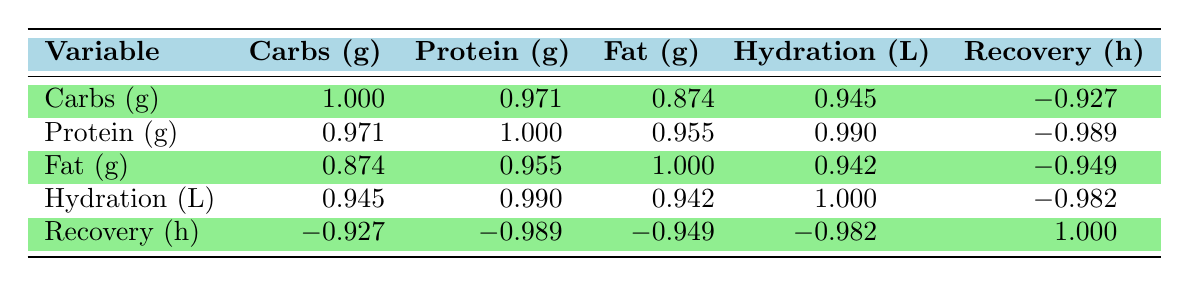What is the correlation between carbohydrate intake and recovery time? The correlation coefficient for carbohydrate intake and recovery time is -0.927, which indicates a strong negative correlation. This means that as carbohydrate intake increases, recovery time tends to decrease.
Answer: -0.927 Which athlete had the highest protein intake? Looking at the table, AthleteID 3 has the highest protein intake of 175 grams.
Answer: 175 grams Is there a strong correlation between hydration and recovery time? The correlation coefficient for hydration and recovery time is -0.982, which indicates a very strong negative correlation. This suggests that higher hydration levels are associated with shorter recovery times.
Answer: Yes What is the average carbohydrate intake of all athletes? To find the average carbohydrate intake, we sum the carbohydrate intakes (300 + 250 + 400 + 350 + 200) = 1500 grams, and divide by the number of athletes (5), giving us an average of 300 grams.
Answer: 300 grams If we compare the protein intake of AthleteID 3 and AthleteID 5, how much higher is AthleteID 3’s protein intake? AthleteID 3 has a protein intake of 175 grams while AthleteID 5 has 100 grams. The difference is 175 - 100 = 75 grams.
Answer: 75 grams Does increasing fat intake correlate positively with protein intake? The correlation coefficient between fat intake and protein intake is 0.955, which indicates a strong positive correlation. This means that as fat intake increases, protein intake also tends to increase.
Answer: Yes What is the relationship between hydration and carbohydrate intake? The correlation coefficient for hydration and carbohydrate intake is 0.945, indicating a strong positive correlation. This suggests that higher hydration levels are associated with higher carbohydrate intake.
Answer: 0.945 What is the total fat intake of all athletes? The total fat intake is found by summing the values (70 + 60 + 80 + 50 + 40) = 300 grams.
Answer: 300 grams Which athlete had the longest recovery time and what was it? AthleteID 5 had the longest recovery time of 35 hours.
Answer: 35 hours 